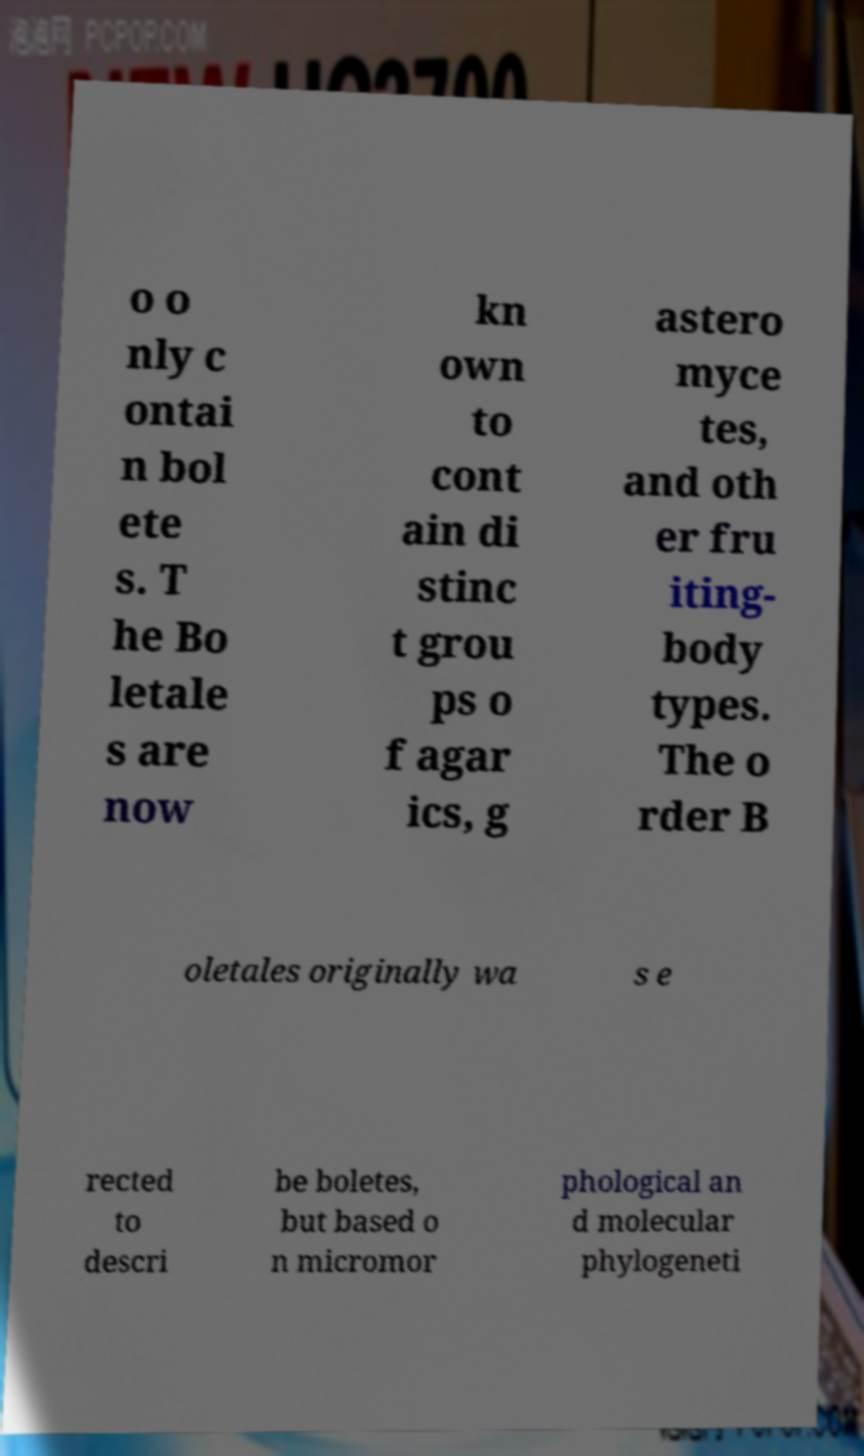Can you read and provide the text displayed in the image?This photo seems to have some interesting text. Can you extract and type it out for me? o o nly c ontai n bol ete s. T he Bo letale s are now kn own to cont ain di stinc t grou ps o f agar ics, g astero myce tes, and oth er fru iting- body types. The o rder B oletales originally wa s e rected to descri be boletes, but based o n micromor phological an d molecular phylogeneti 